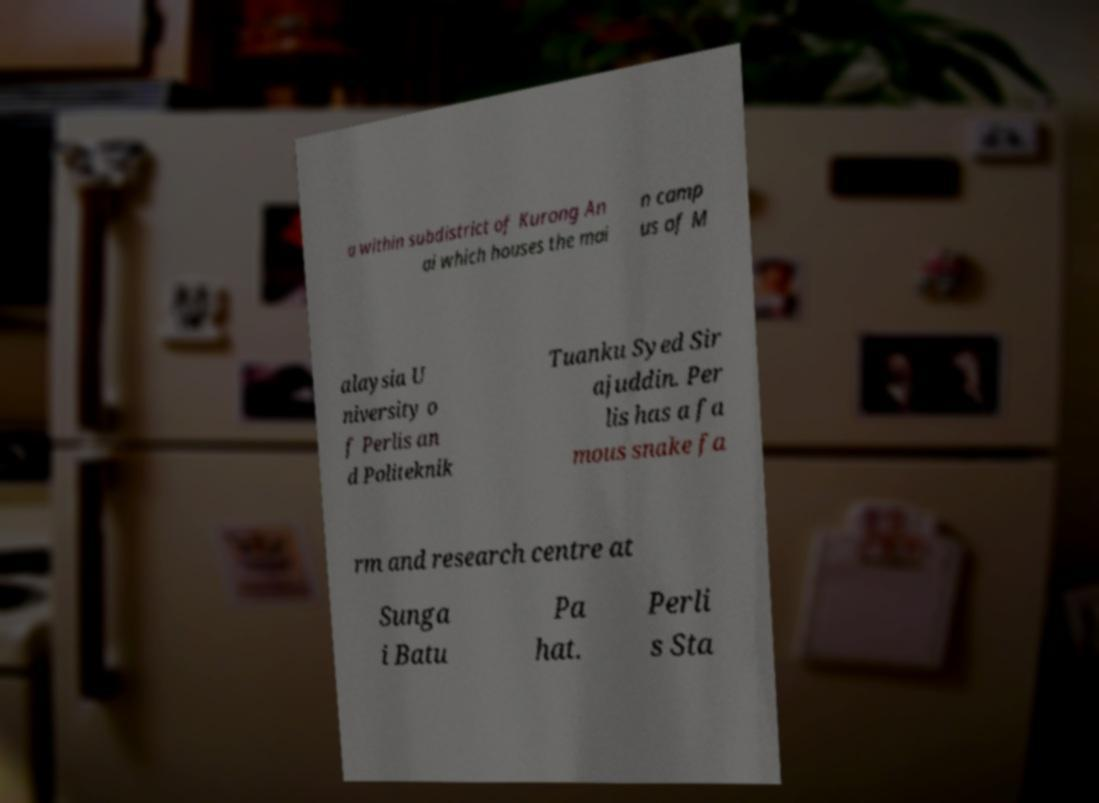I need the written content from this picture converted into text. Can you do that? a within subdistrict of Kurong An ai which houses the mai n camp us of M alaysia U niversity o f Perlis an d Politeknik Tuanku Syed Sir ajuddin. Per lis has a fa mous snake fa rm and research centre at Sunga i Batu Pa hat. Perli s Sta 